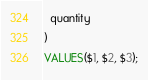<code> <loc_0><loc_0><loc_500><loc_500><_SQL_>  quantity
)
VALUES($1, $2, $3);
</code> 